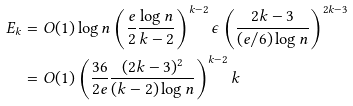Convert formula to latex. <formula><loc_0><loc_0><loc_500><loc_500>E _ { k } & = O ( 1 ) \log n \left ( \frac { e } 2 \frac { \log n } { k - 2 } \right ) ^ { k - 2 } \epsilon \left ( \frac { 2 k - 3 } { ( e / 6 ) \log n } \right ) ^ { 2 k - 3 } \\ & = O ( 1 ) \left ( \frac { 3 6 } { 2 e } \frac { ( 2 k - 3 ) ^ { 2 } } { ( k - 2 ) \log n } \right ) ^ { k - 2 } k</formula> 